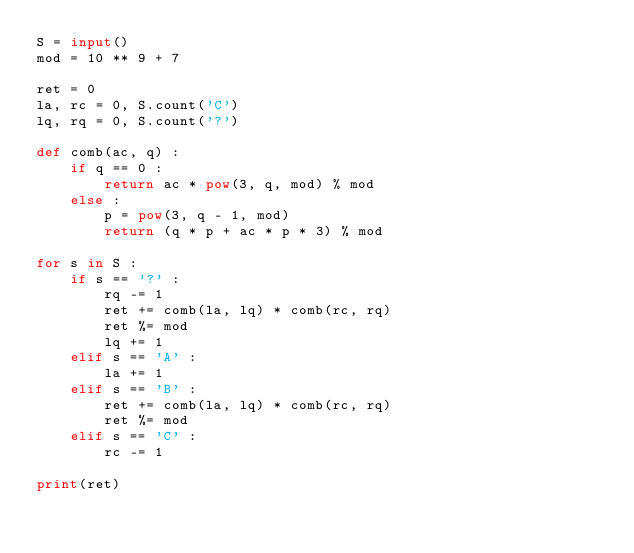<code> <loc_0><loc_0><loc_500><loc_500><_Python_>S = input()
mod = 10 ** 9 + 7

ret = 0
la, rc = 0, S.count('C')
lq, rq = 0, S.count('?')

def comb(ac, q) :
    if q == 0 :
        return ac * pow(3, q, mod) % mod
    else :
        p = pow(3, q - 1, mod)
        return (q * p + ac * p * 3) % mod

for s in S :
    if s == '?' :
        rq -= 1
        ret += comb(la, lq) * comb(rc, rq)
        ret %= mod
        lq += 1
    elif s == 'A' :
        la += 1
    elif s == 'B' :
        ret += comb(la, lq) * comb(rc, rq)
        ret %= mod
    elif s == 'C' :
        rc -= 1
    
print(ret)</code> 